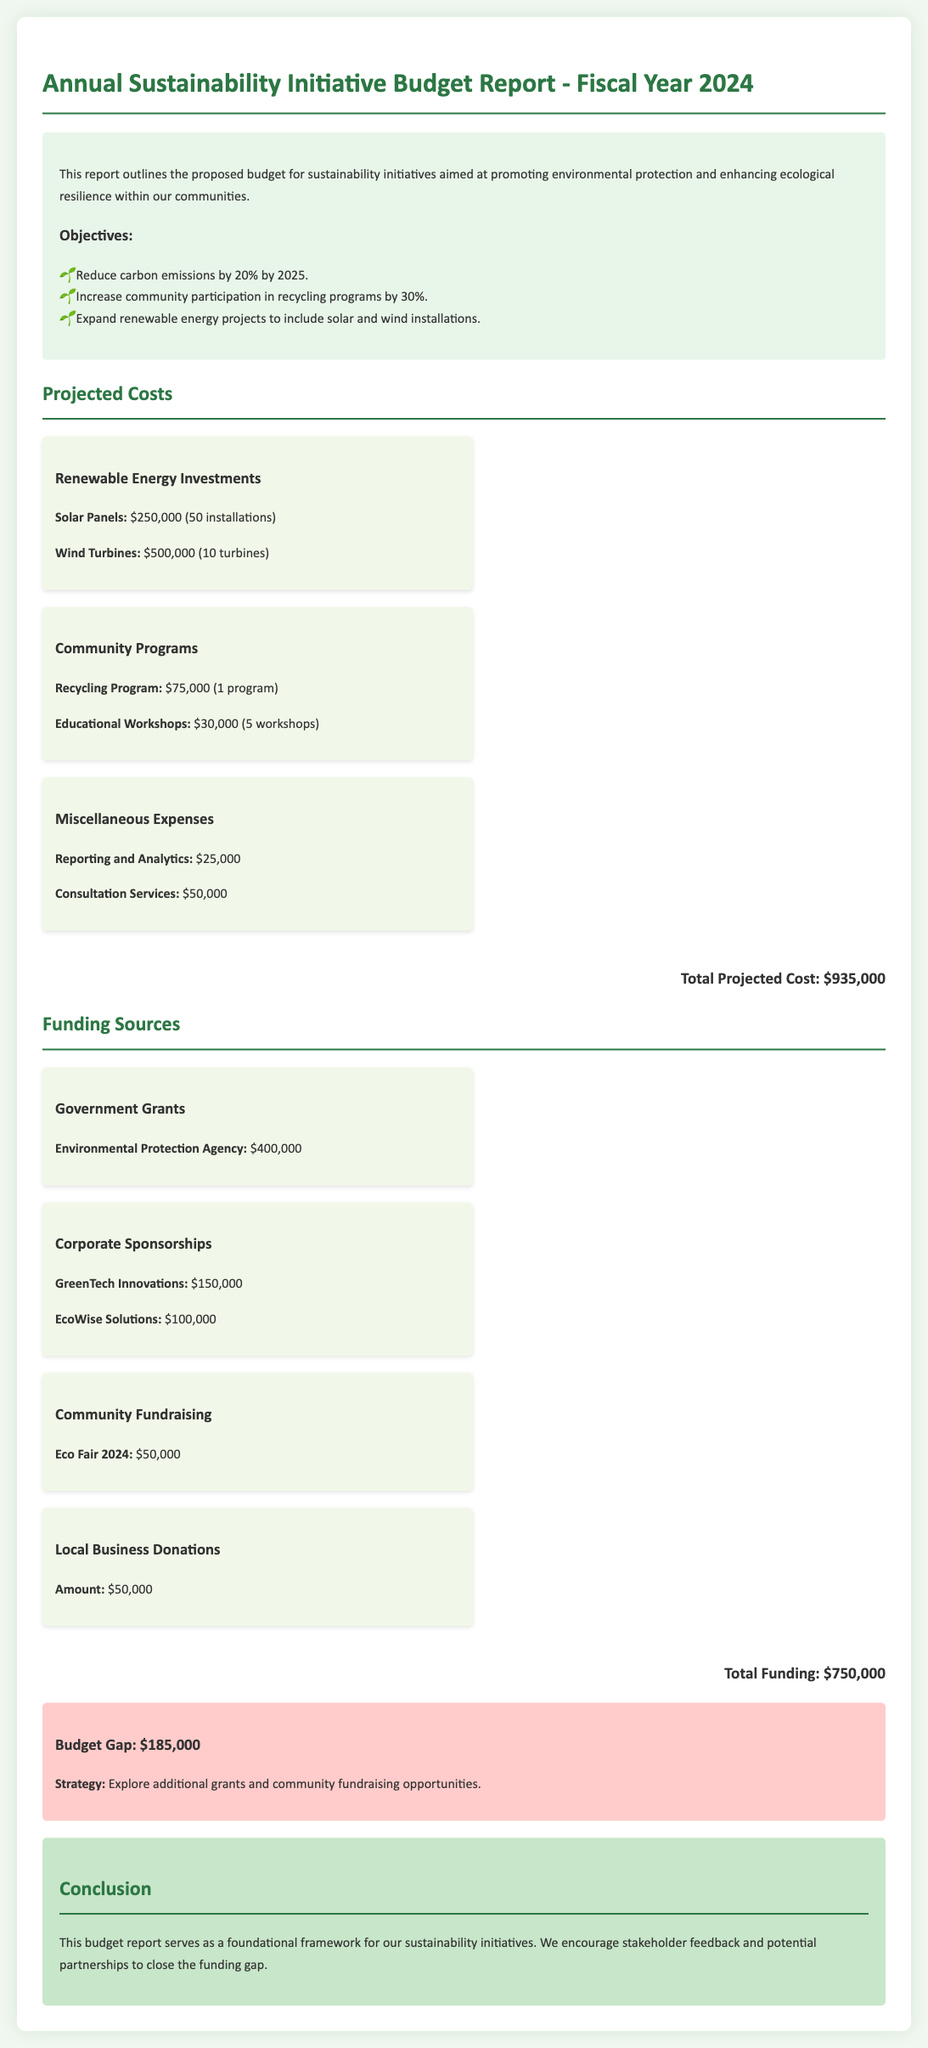What is the total projected cost? The total projected cost is listed at the bottom of the projected costs section in the document.
Answer: $935,000 How much funding comes from Government Grants? Government Grants are specified as one of the funding sources, detailing the amount provided by the Environmental Protection Agency.
Answer: $400,000 What is the budget gap amount? The budget gap is found in the budget gap section, which outlines the financial shortfall.
Answer: $185,000 How many solar panel installations are planned? The number of solar panel installations is stated beside the Solar Panels cost.
Answer: 50 installations What is the total amount contributed by corporate sponsorships? Corporate sponsorships are detailed in the funding sources section with specific contributions from two companies.
Answer: $250,000 What is the objective related to recycling programs? The objectives outline specific goals to be achieved, one of which pertains to recycling programs.
Answer: Increase community participation by 30% What are the total expenses for community programs? Total expenses for community programs combine the costs of the Recycling Program and Educational Workshops listed together.
Answer: $105,000 Which company contributed $100,000 to the funding? A specific corporate sponsor that is mentioned in the document as providing this funding is clearly identified.
Answer: EcoWise Solutions How many educational workshops are funded? The number of educational workshops funded is directly mentioned in the projected costs section under Community Programs.
Answer: 5 workshops 